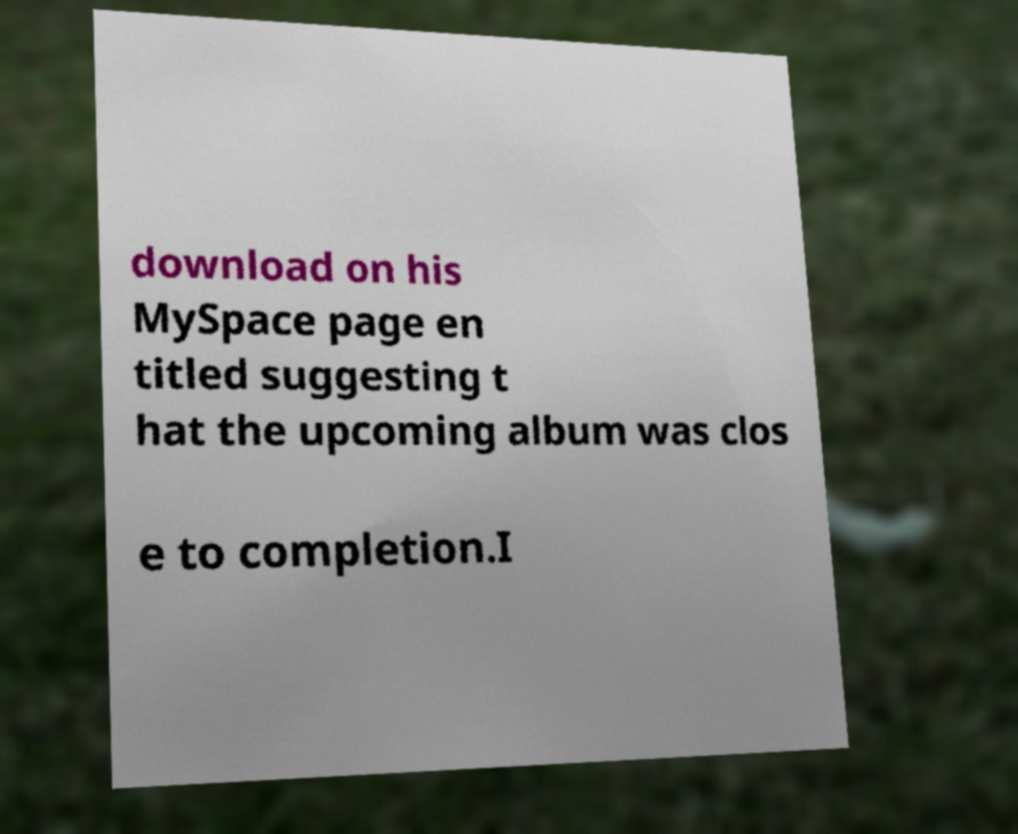There's text embedded in this image that I need extracted. Can you transcribe it verbatim? download on his MySpace page en titled suggesting t hat the upcoming album was clos e to completion.I 